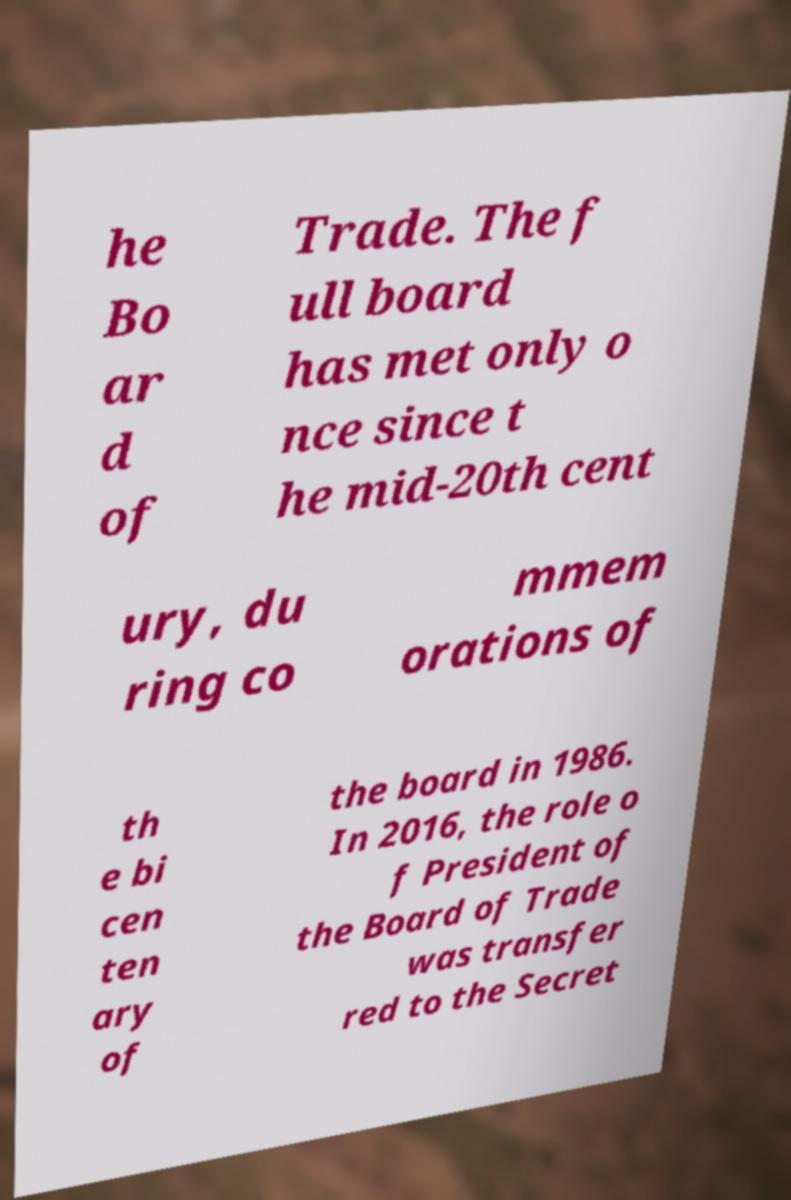Could you extract and type out the text from this image? he Bo ar d of Trade. The f ull board has met only o nce since t he mid-20th cent ury, du ring co mmem orations of th e bi cen ten ary of the board in 1986. In 2016, the role o f President of the Board of Trade was transfer red to the Secret 